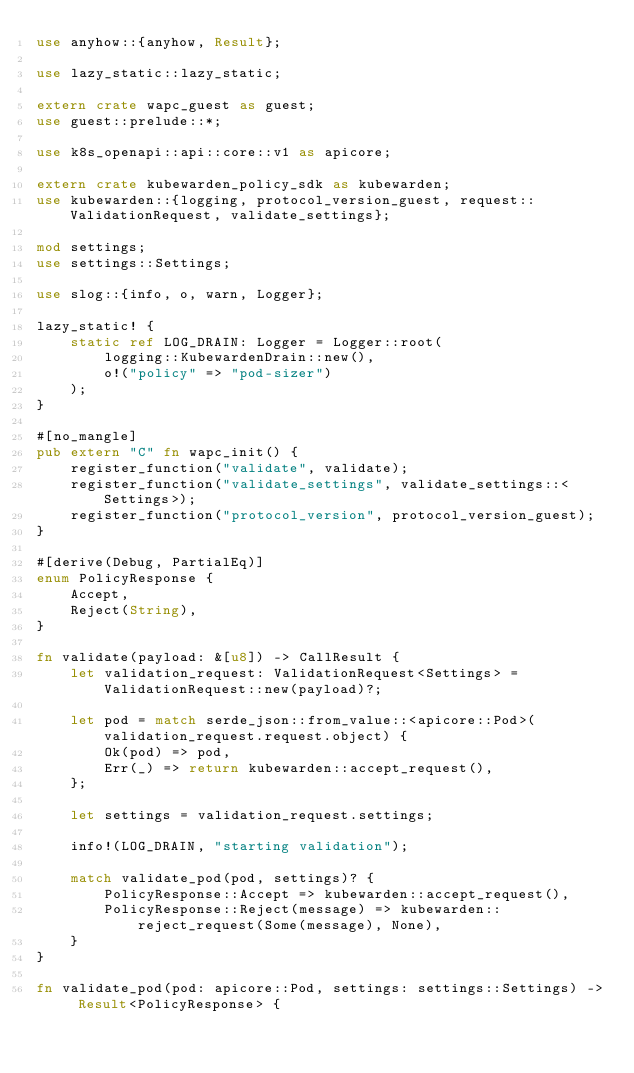<code> <loc_0><loc_0><loc_500><loc_500><_Rust_>use anyhow::{anyhow, Result};

use lazy_static::lazy_static;

extern crate wapc_guest as guest;
use guest::prelude::*;

use k8s_openapi::api::core::v1 as apicore;

extern crate kubewarden_policy_sdk as kubewarden;
use kubewarden::{logging, protocol_version_guest, request::ValidationRequest, validate_settings};

mod settings;
use settings::Settings;

use slog::{info, o, warn, Logger};

lazy_static! {
    static ref LOG_DRAIN: Logger = Logger::root(
        logging::KubewardenDrain::new(),
        o!("policy" => "pod-sizer")
    );
}

#[no_mangle]
pub extern "C" fn wapc_init() {
    register_function("validate", validate);
    register_function("validate_settings", validate_settings::<Settings>);
    register_function("protocol_version", protocol_version_guest);
}

#[derive(Debug, PartialEq)]
enum PolicyResponse {
    Accept,
    Reject(String),
}

fn validate(payload: &[u8]) -> CallResult {
    let validation_request: ValidationRequest<Settings> = ValidationRequest::new(payload)?;

    let pod = match serde_json::from_value::<apicore::Pod>(validation_request.request.object) {
        Ok(pod) => pod,
        Err(_) => return kubewarden::accept_request(),
    };

    let settings = validation_request.settings;

    info!(LOG_DRAIN, "starting validation");

    match validate_pod(pod, settings)? {
        PolicyResponse::Accept => kubewarden::accept_request(),
        PolicyResponse::Reject(message) => kubewarden::reject_request(Some(message), None),
    }
}

fn validate_pod(pod: apicore::Pod, settings: settings::Settings) -> Result<PolicyResponse> {</code> 